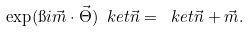<formula> <loc_0><loc_0><loc_500><loc_500>\exp ( \i i \vec { m } \cdot \vec { \Theta } ) \ k e t { \vec { n } } = \ k e t { \vec { n } + \vec { m } } .</formula> 